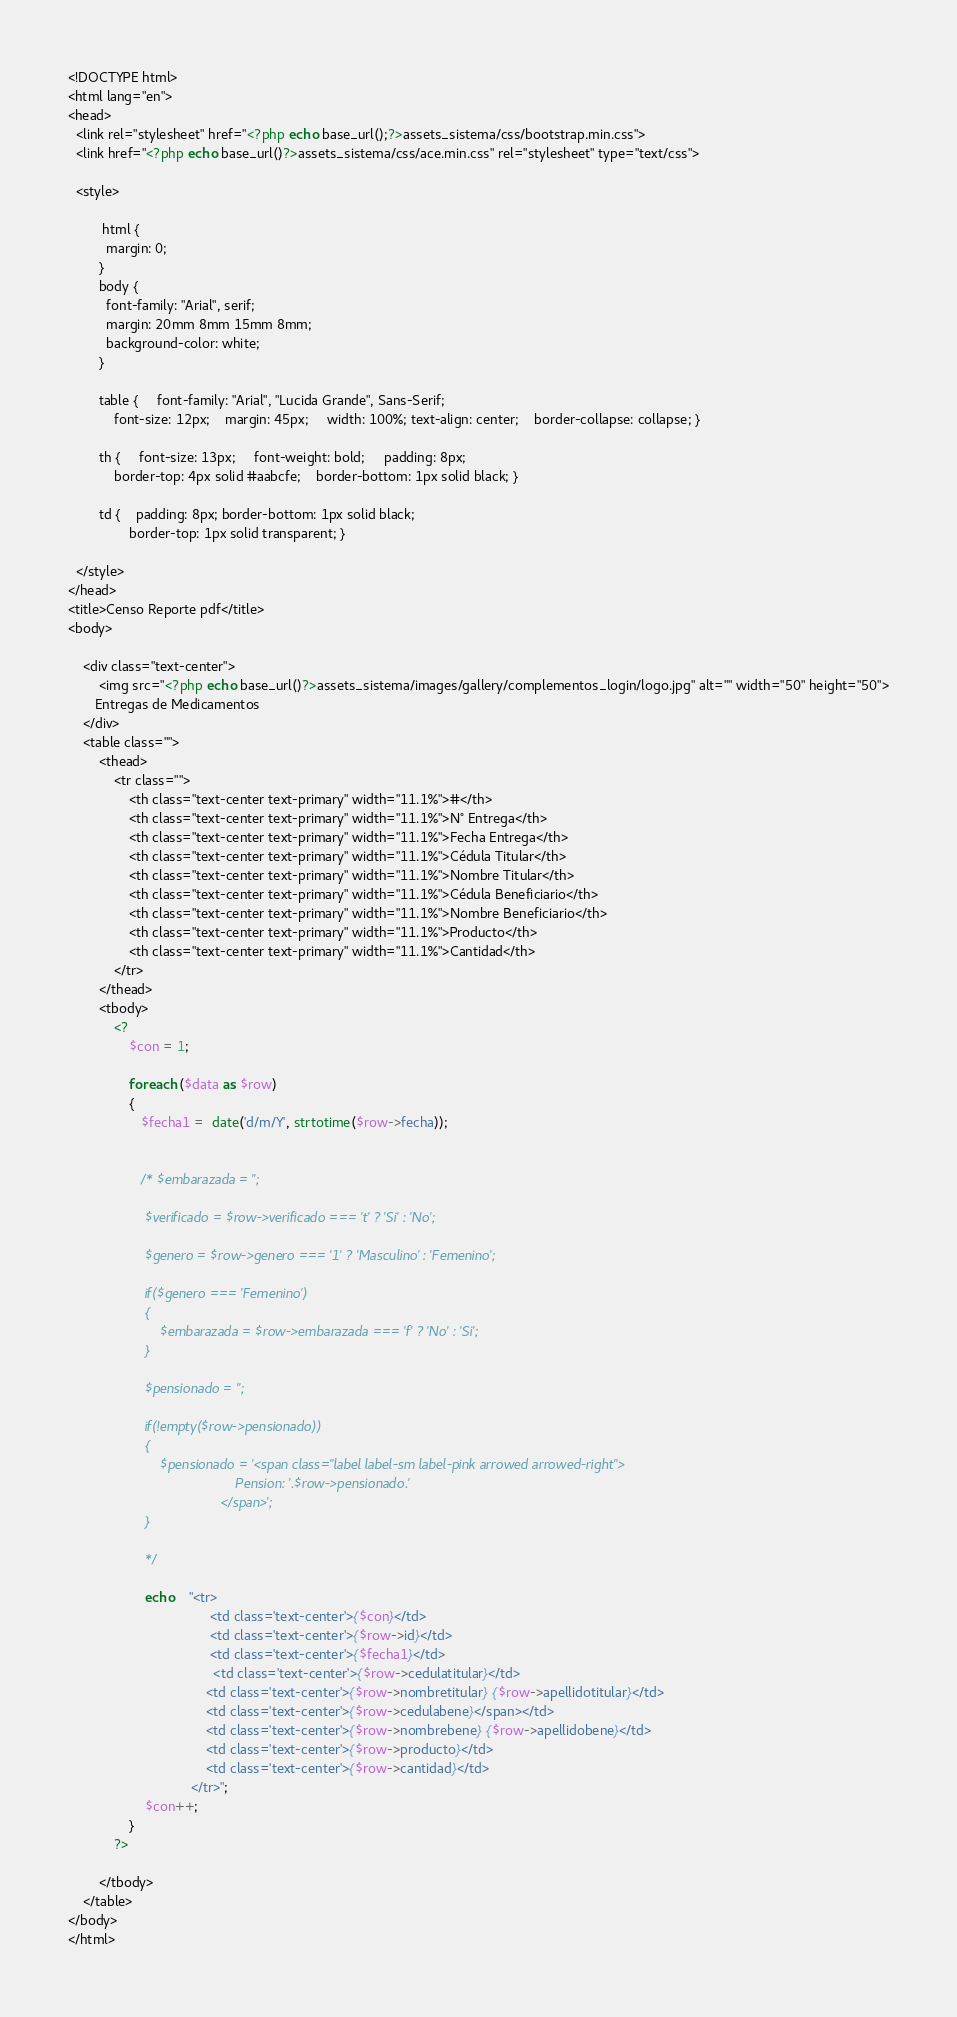<code> <loc_0><loc_0><loc_500><loc_500><_PHP_><!DOCTYPE html>
<html lang="en">  
<head>
  <link rel="stylesheet" href="<?php echo base_url();?>assets_sistema/css/bootstrap.min.css">
  <link href="<?php echo base_url()?>assets_sistema/css/ace.min.css" rel="stylesheet" type="text/css">

  <style>

         html {
          margin: 0;
        }
        body {
          font-family: "Arial", serif;
          margin: 20mm 8mm 15mm 8mm;
          background-color: white;
        }

        table {     font-family: "Arial", "Lucida Grande", Sans-Serif;
            font-size: 12px;    margin: 45px;     width: 100%; text-align: center;    border-collapse: collapse; }

        th {     font-size: 13px;     font-weight: bold;     padding: 8px;
            border-top: 4px solid #aabcfe;    border-bottom: 1px solid black; }

        td {    padding: 8px; border-bottom: 1px solid black;
                border-top: 1px solid transparent; }

  </style>
</head>
<title>Censo Reporte pdf</title>
<body>
    
    <div class="text-center">
        <img src="<?php echo base_url()?>assets_sistema/images/gallery/complementos_login/logo.jpg" alt="" width="50" height="50">
       Entregas de Medicamentos
    </div>
    <table class="">
        <thead>
            <tr class="">
                <th class="text-center text-primary" width="11.1%">#</th>
                <th class="text-center text-primary" width="11.1%">N° Entrega</th>
                <th class="text-center text-primary" width="11.1%">Fecha Entrega</th>
                <th class="text-center text-primary" width="11.1%">Cédula Titular</th>
                <th class="text-center text-primary" width="11.1%">Nombre Titular</th>
                <th class="text-center text-primary" width="11.1%">Cédula Beneficiario</th>
                <th class="text-center text-primary" width="11.1%">Nombre Beneficiario</th>                     
                <th class="text-center text-primary" width="11.1%">Producto</th>
                <th class="text-center text-primary" width="11.1%">Cantidad</th>
            </tr>
        </thead>
        <tbody>
            <?
                $con = 1;

                foreach ($data as $row) 
                {
                   $fecha1 =  date('d/m/Y', strtotime($row->fecha)); 
                   

                   /* $embarazada = '';
                    
                    $verificado = $row->verificado === 't' ? 'Si' : 'No';

                    $genero = $row->genero === '1' ? 'Masculino' : 'Femenino';

                    if($genero === 'Femenino')
                    {
                        $embarazada = $row->embarazada === 'f' ? 'No' : 'Si';
                    }

                    $pensionado = '';

                    if(!empty($row->pensionado))
                    {
                        $pensionado = '<span class="label label-sm label-pink arrowed arrowed-right">
                                            Pension: '.$row->pensionado.'
                                        </span>';
                    }

                    */

                    echo    "<tr>
                                     <td class='text-center'>{$con}</td>
                                     <td class='text-center'>{$row->id}</td>
                                     <td class='text-center'>{$fecha1}</td>
                                      <td class='text-center'>{$row->cedulatitular}</td>
                                    <td class='text-center'>{$row->nombretitular} {$row->apellidotitular}</td>
                                    <td class='text-center'>{$row->cedulabene}</span></td>
                                    <td class='text-center'>{$row->nombrebene} {$row->apellidobene}</td>
                                    <td class='text-center'>{$row->producto}</td>
                                    <td class='text-center'>{$row->cantidad}</td>
                                </tr>";
                    $con++;
                }
            ?>
 
        </tbody>
    </table>
</body>
</html></code> 